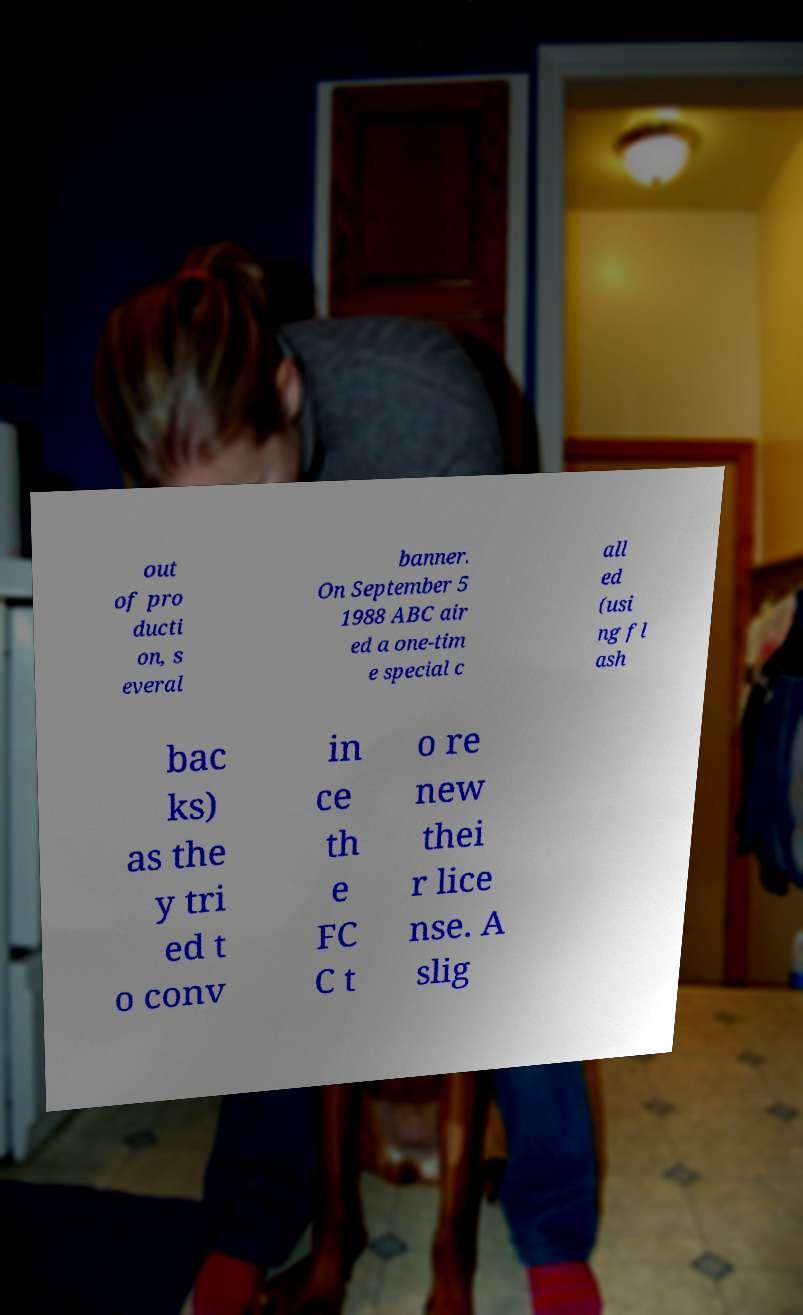Please read and relay the text visible in this image. What does it say? out of pro ducti on, s everal banner. On September 5 1988 ABC air ed a one-tim e special c all ed (usi ng fl ash bac ks) as the y tri ed t o conv in ce th e FC C t o re new thei r lice nse. A slig 